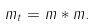Convert formula to latex. <formula><loc_0><loc_0><loc_500><loc_500>m _ { t } = m * m .</formula> 